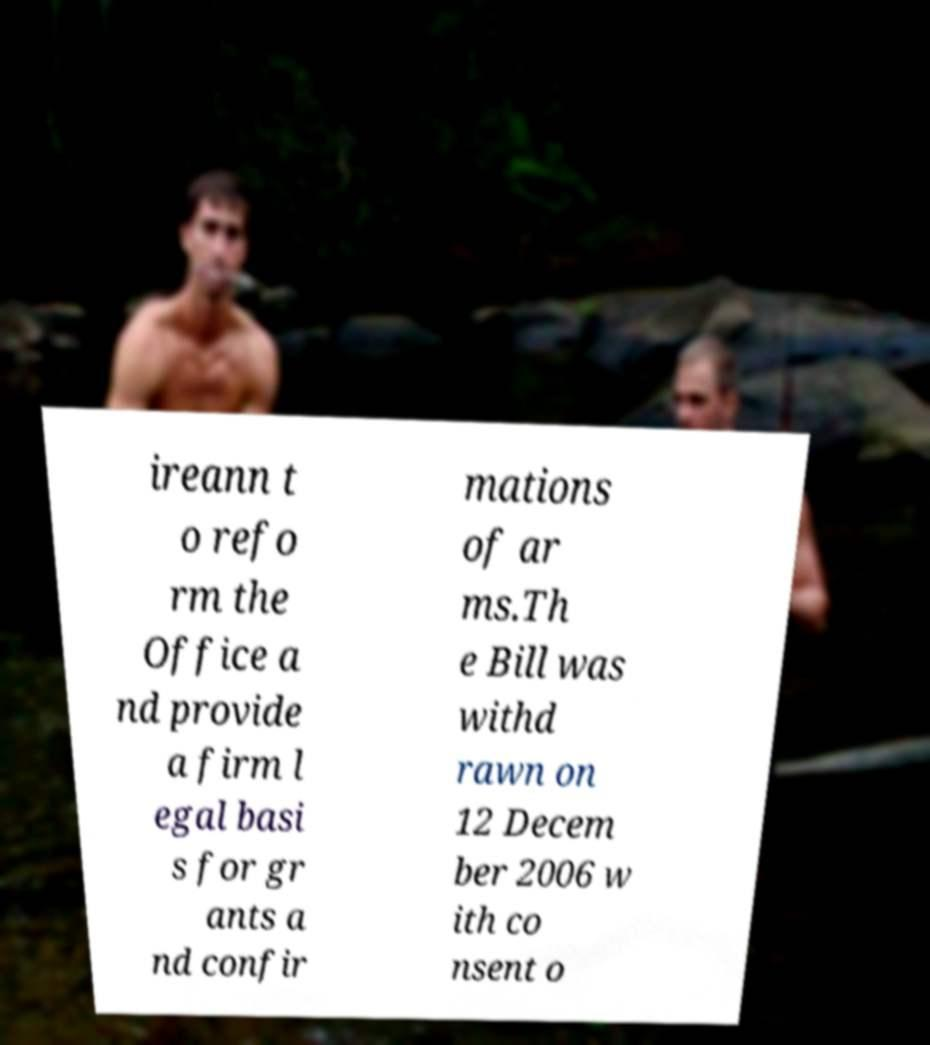I need the written content from this picture converted into text. Can you do that? ireann t o refo rm the Office a nd provide a firm l egal basi s for gr ants a nd confir mations of ar ms.Th e Bill was withd rawn on 12 Decem ber 2006 w ith co nsent o 